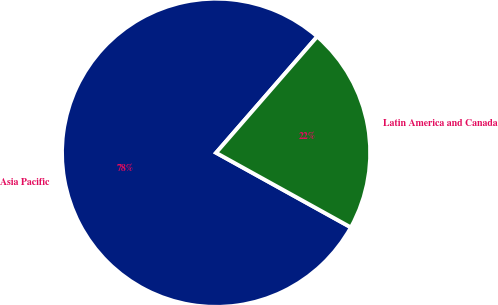Convert chart to OTSL. <chart><loc_0><loc_0><loc_500><loc_500><pie_chart><fcel>Asia Pacific<fcel>Latin America and Canada<nl><fcel>78.35%<fcel>21.65%<nl></chart> 